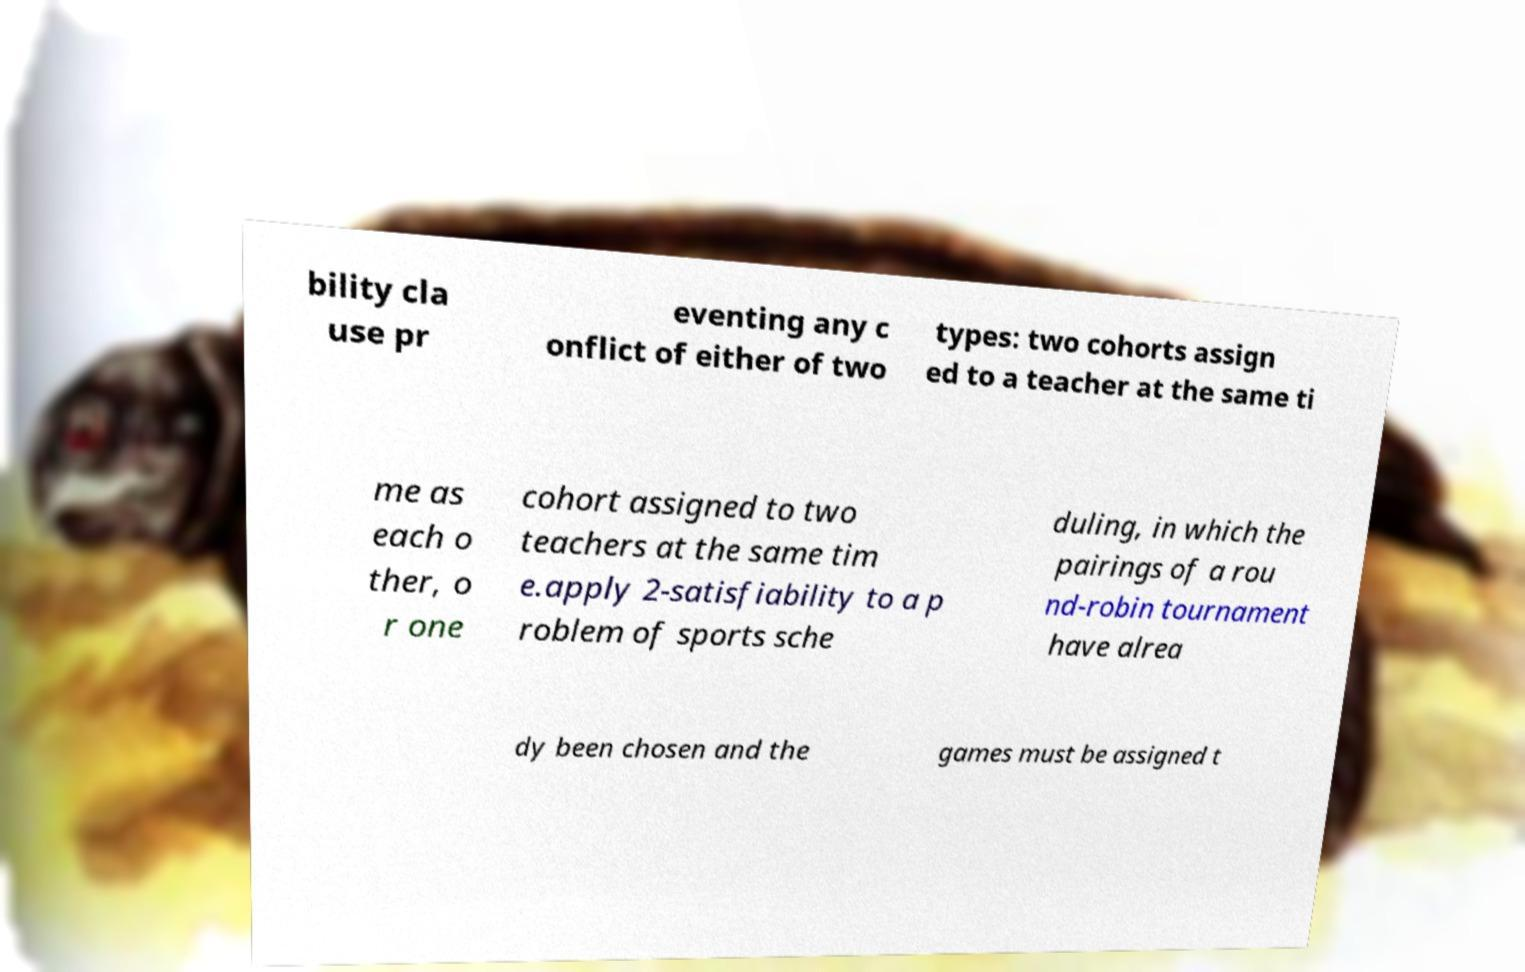Can you accurately transcribe the text from the provided image for me? bility cla use pr eventing any c onflict of either of two types: two cohorts assign ed to a teacher at the same ti me as each o ther, o r one cohort assigned to two teachers at the same tim e.apply 2-satisfiability to a p roblem of sports sche duling, in which the pairings of a rou nd-robin tournament have alrea dy been chosen and the games must be assigned t 